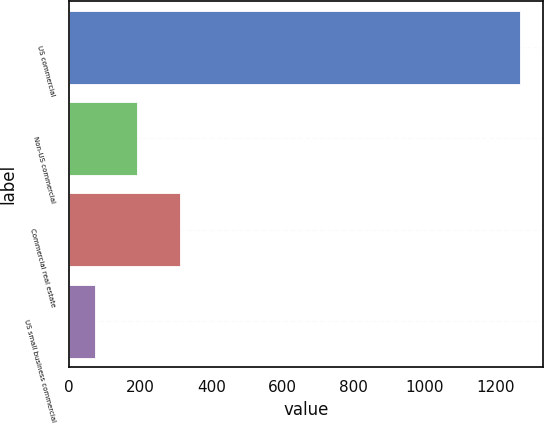Convert chart to OTSL. <chart><loc_0><loc_0><loc_500><loc_500><bar_chart><fcel>US commercial<fcel>Non-US commercial<fcel>Commercial real estate<fcel>US small business commercial<nl><fcel>1270<fcel>191.8<fcel>311.6<fcel>72<nl></chart> 